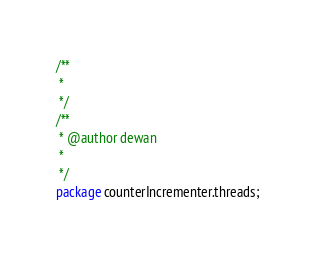<code> <loc_0><loc_0><loc_500><loc_500><_Java_>/**
 * 
 */
/**
 * @author dewan
 *
 */
package counterIncrementer.threads;</code> 